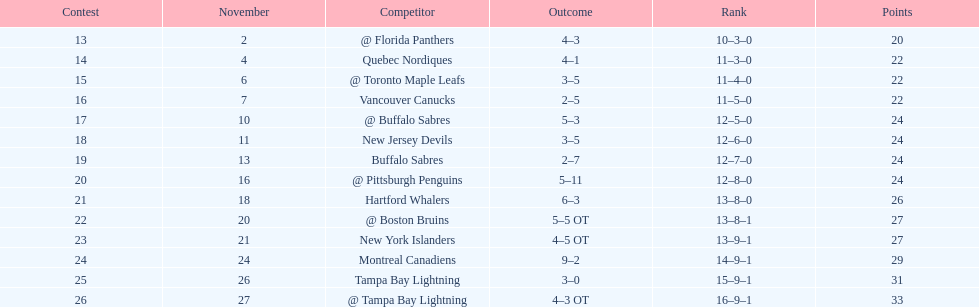Did the tampa bay lightning have the least amount of wins? Yes. 